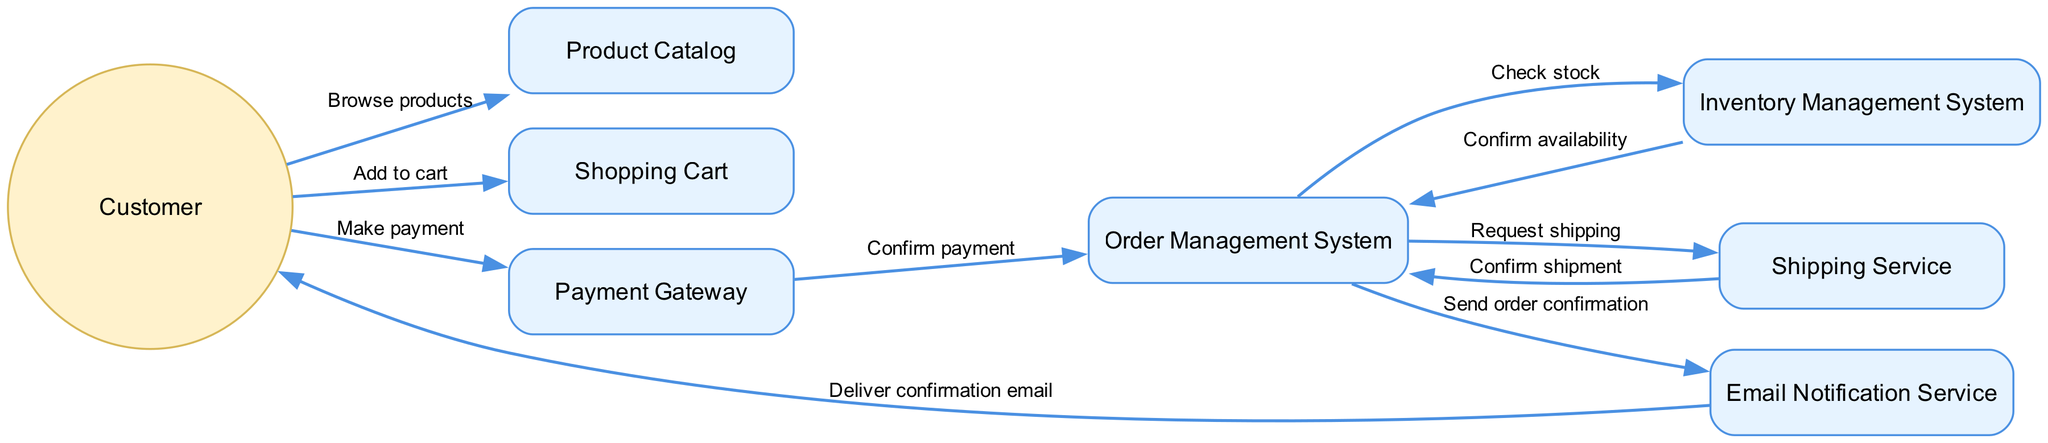What is the first action taken by the customer? The first interaction in the sequence diagram is 'Browse products', which is initiated by the Customer towards the Product Catalog.
Answer: Browse products How many systems are involved in this workflow? The diagram includes 6 systems: Product Catalog, Shopping Cart, Payment Gateway, Order Management System, Inventory Management System, Shipping Service, and Email Notification Service for a total of 7 systems.
Answer: 7 systems Who does the customer receive the confirmation email from? The final action in the sequence diagram indicates that the Email Notification Service delivers a confirmation email to the Customer.
Answer: Email Notification Service What action confirms the payment with the Order Management System? The interaction labeled 'Confirm payment' occurs between the Payment Gateway and the Order Management System, indicating that this action confirms the payment.
Answer: Confirm payment Which system checks stock availability? In the workflow, the Inventory Management System is responsible for checking the stock when the Order Management System requests to confirm availability.
Answer: Inventory Management System What happens after the Order Management System requests shipping? Following the action 'Request shipping', the Shipping Service sends a 'Confirm shipment' response back to the Order Management System indicating the shipping process has been confirmed to take place.
Answer: Confirm shipment How many interactions occur in total? By counting all the labeled edges between the nodes, we identify a total of 10 interactions in the sequence diagram that reflect the order processing workflow.
Answer: 10 interactions Which actor initiates the order processing workflow? The diagram begins with the Customer initiating the process by the first interaction, which is 'Browse products'.
Answer: Customer What is the role of the Email Notification Service in this workflow? The Email Notification Service sends out a confirmation email to the Customer once the order has been processed by providing the final message in the sequence of actions.
Answer: Send order confirmation 